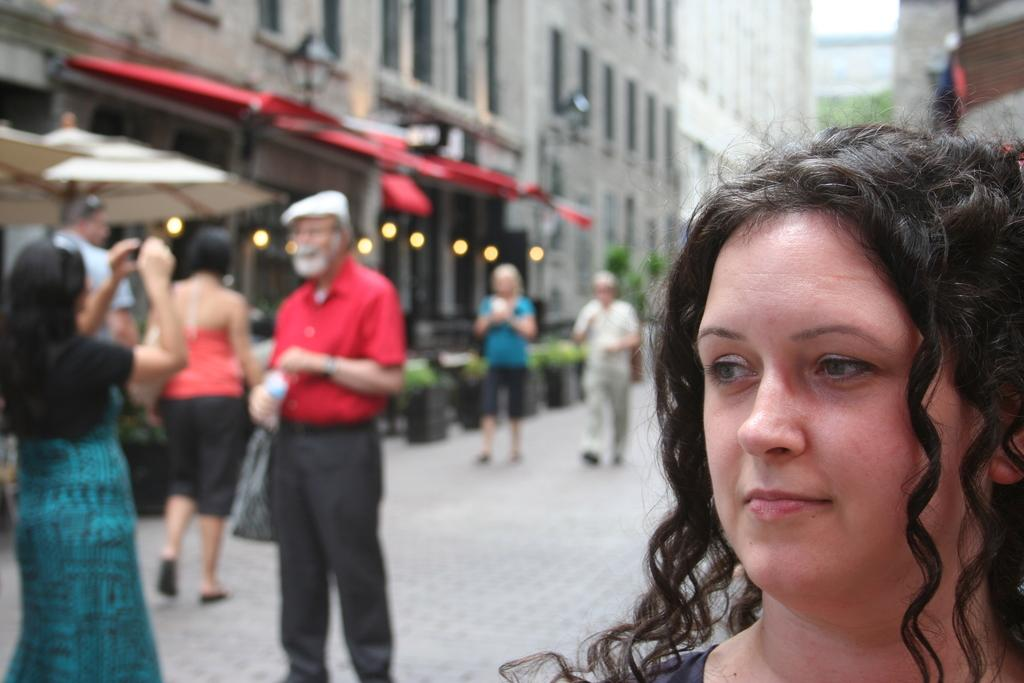Who is the main subject on the right side of the image? There is a woman standing at the right side of the image. Can you describe the other people in the image? There are other people in the image, but their specific positions or actions are not mentioned in the provided facts. What can be seen in the background of the image? There are buildings in the background of the image. What direction is the swing facing in the image? There is no swing present in the image. What type of loss is being experienced by the woman in the image? The provided facts do not mention any loss or emotional state of the woman in the image. 